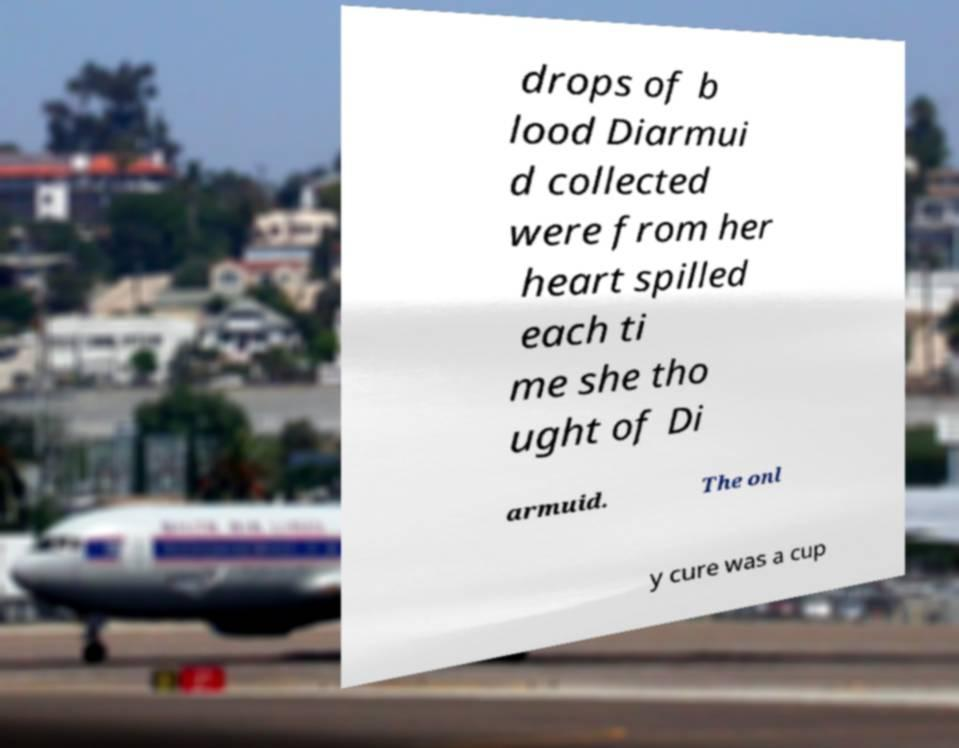Please identify and transcribe the text found in this image. drops of b lood Diarmui d collected were from her heart spilled each ti me she tho ught of Di armuid. The onl y cure was a cup 